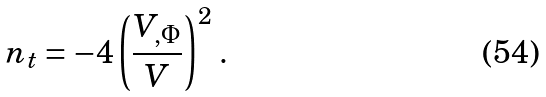<formula> <loc_0><loc_0><loc_500><loc_500>n _ { t } = - 4 \left ( \frac { V _ { , \Phi } } { V } \right ) ^ { 2 } \, .</formula> 